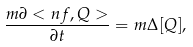<formula> <loc_0><loc_0><loc_500><loc_500>\frac { m \partial < n f , Q > } { \partial t } = m \Delta [ Q ] ,</formula> 